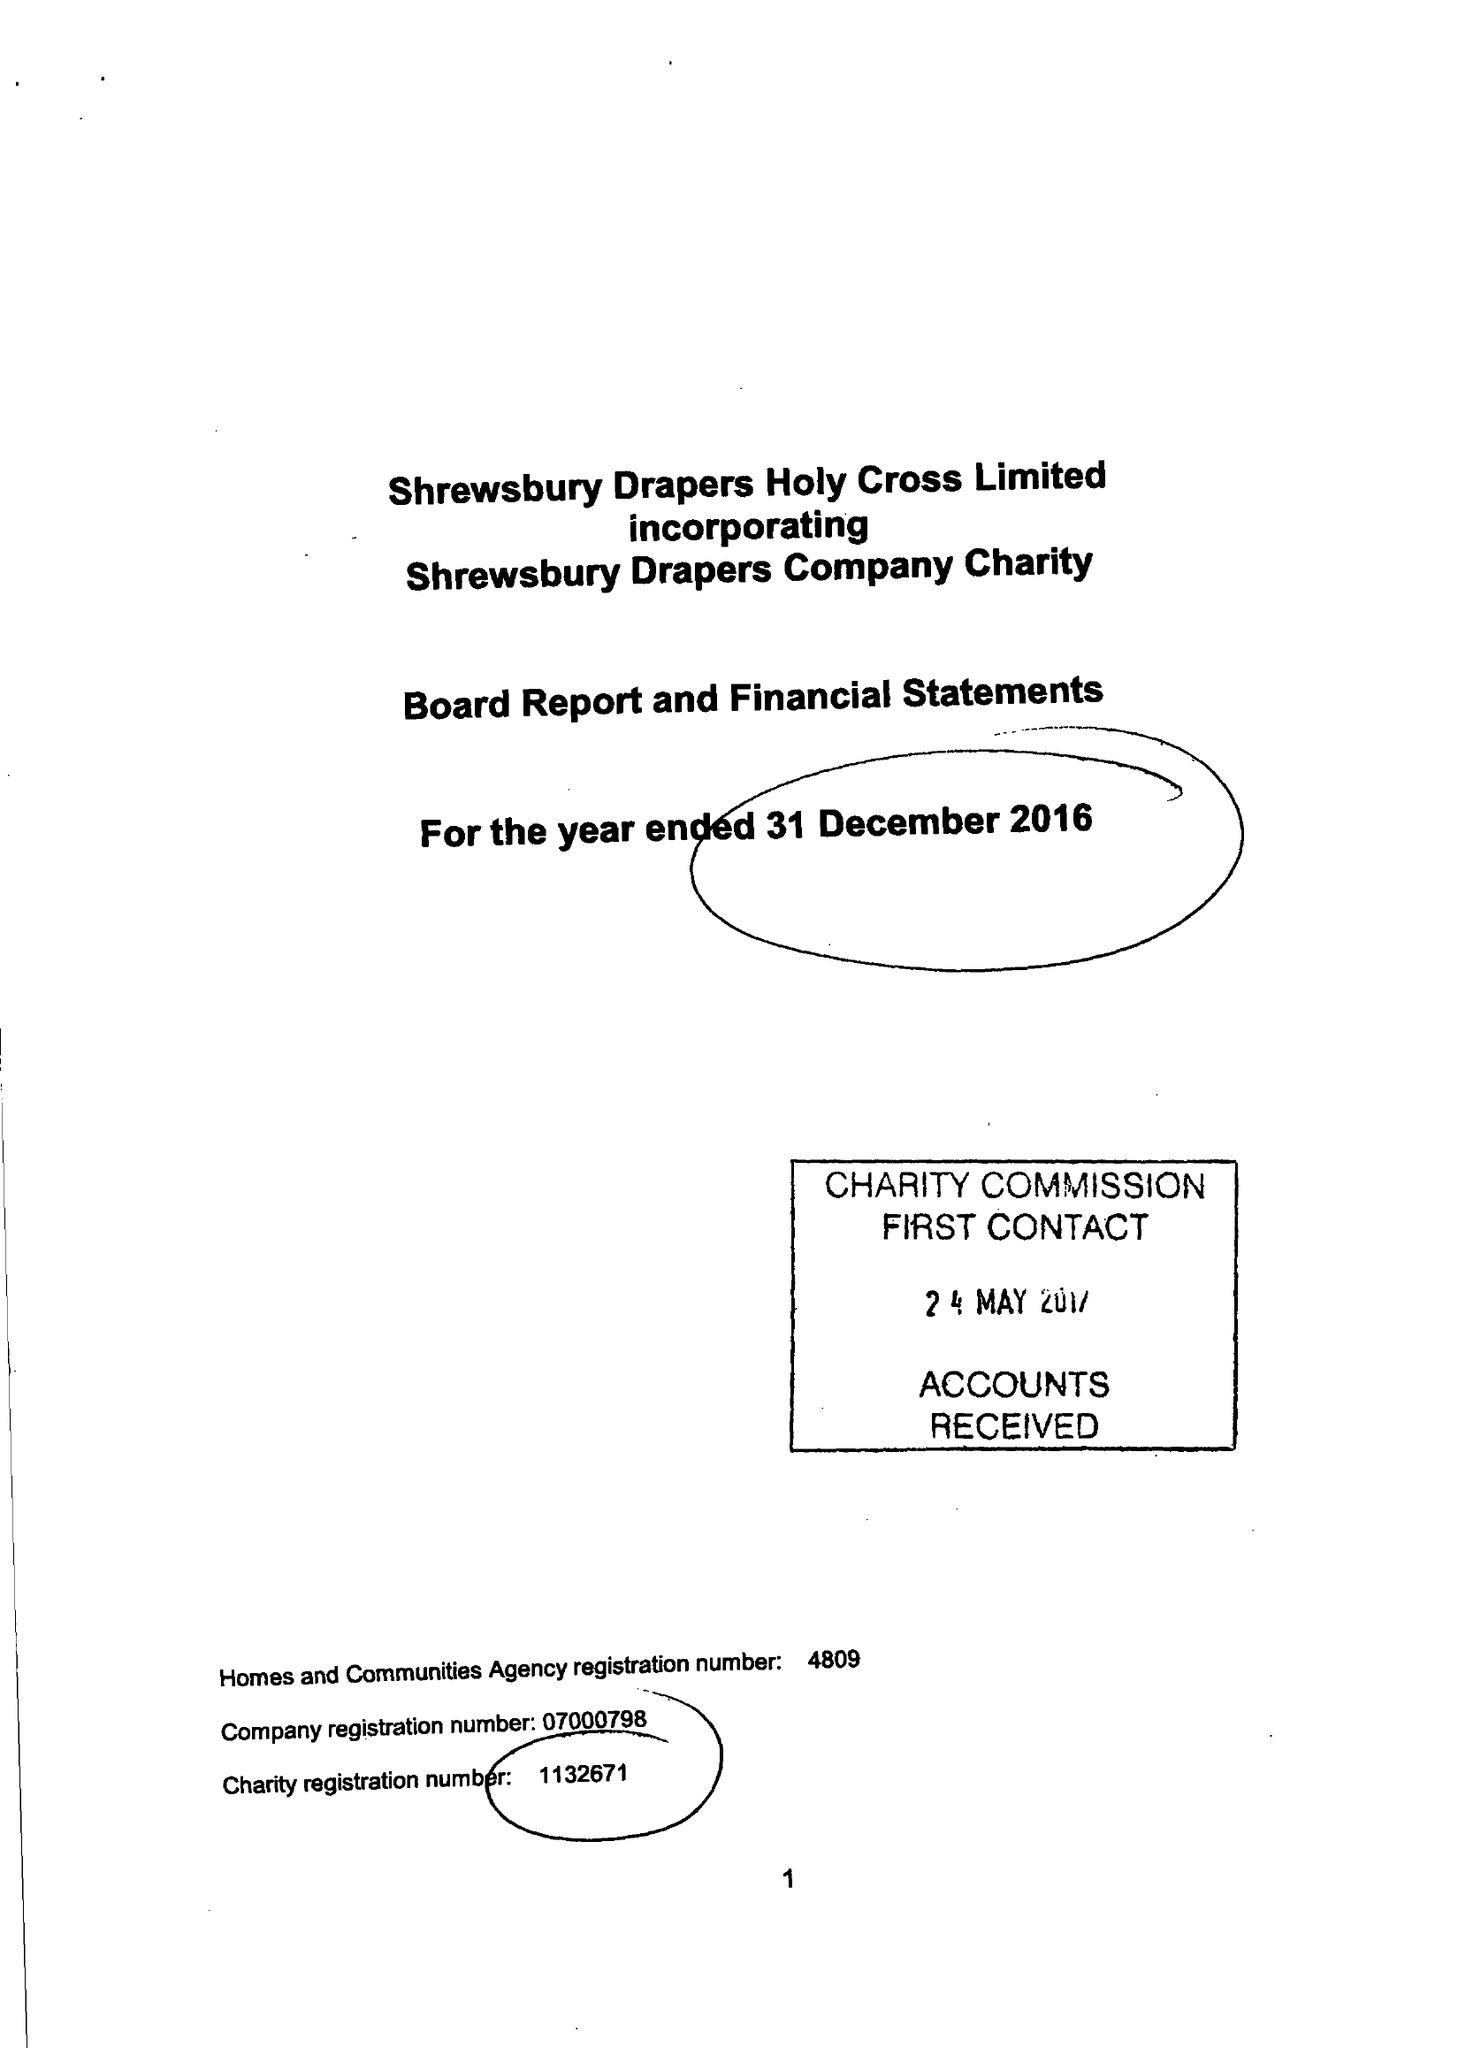What is the value for the charity_number?
Answer the question using a single word or phrase. 1132671 